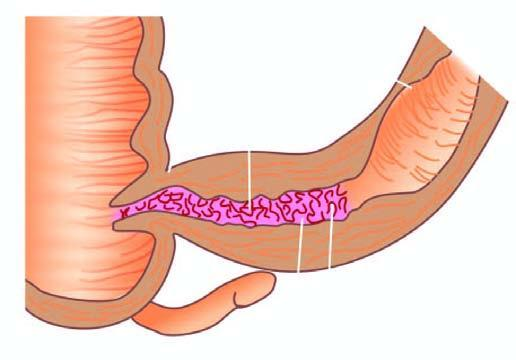where is the specimen of small intestine shown?
Answer the question using a single word or phrase. In longitudinal section 